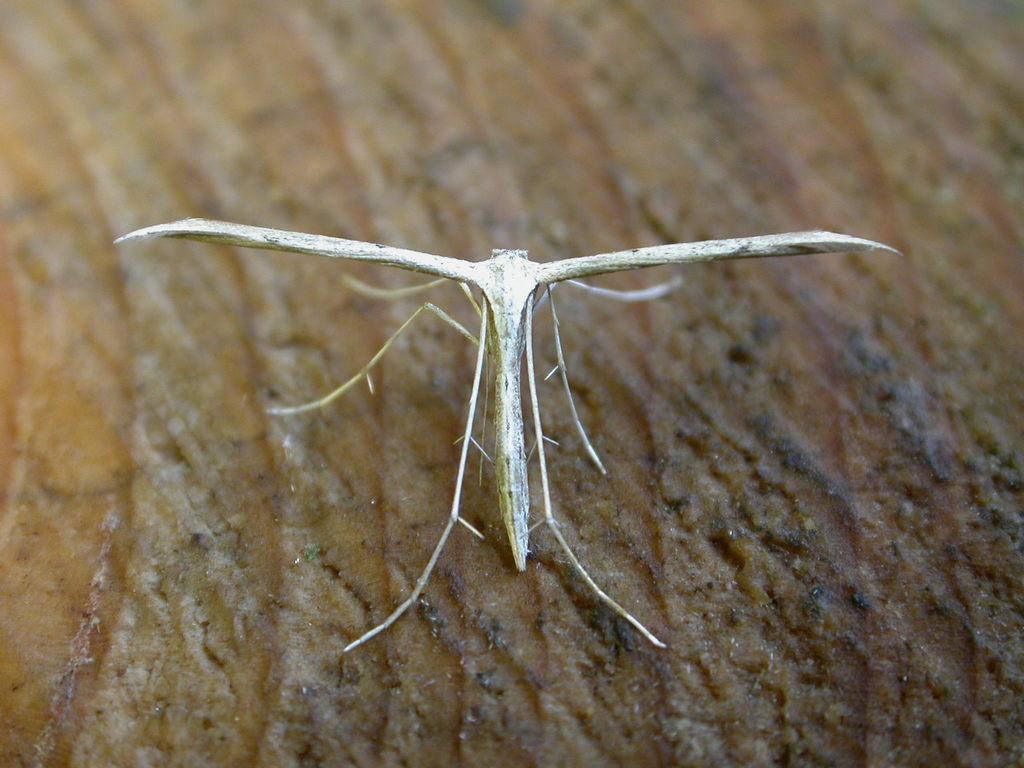How would you summarize this image in a sentence or two? In this picture I can see an insect on an object. 